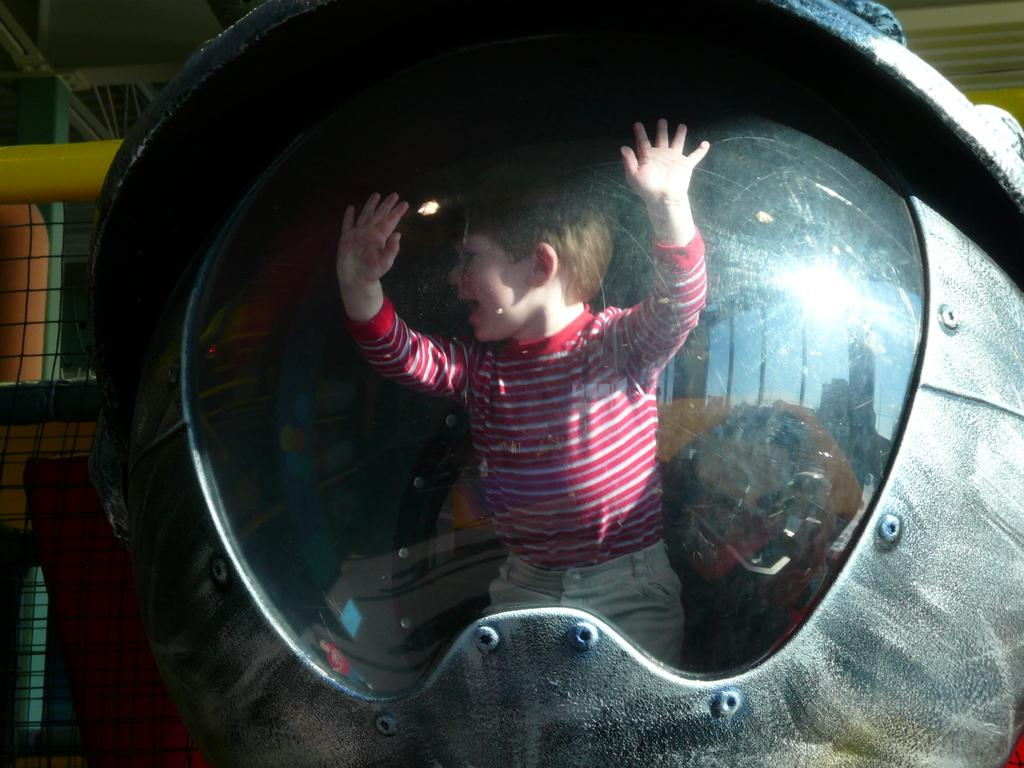What is the main subject of the image? The main subject of the image is a kid. Where is the kid located? The kid is in a metal object. What can be seen in the background of the image? There is fencing in the background of the image. What type of cave can be seen behind the kid in the image? There is no cave present in the image; the background features fencing. 